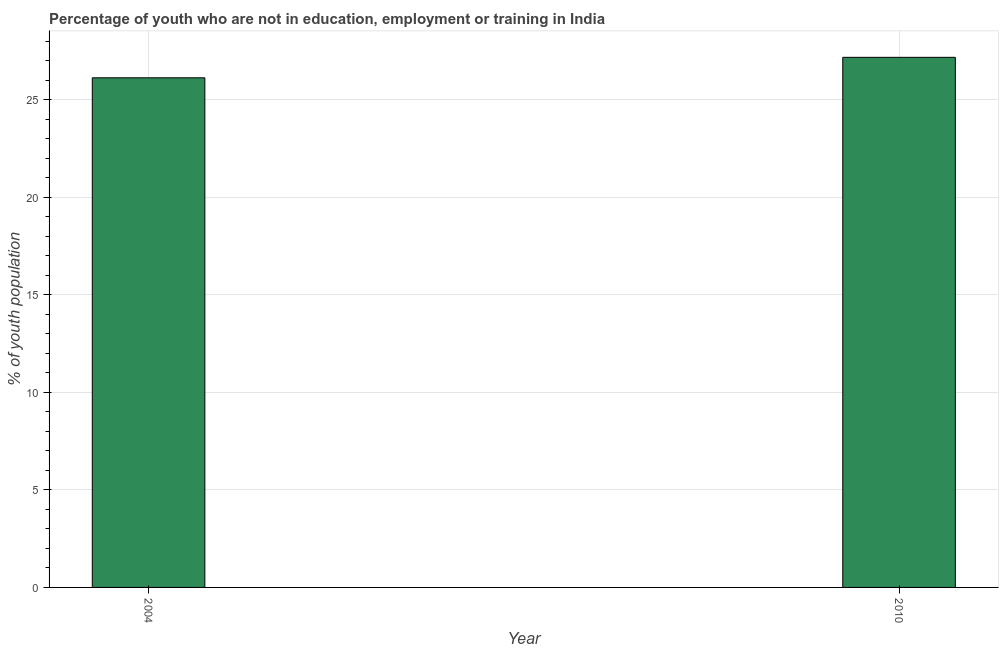Does the graph contain any zero values?
Give a very brief answer. No. Does the graph contain grids?
Your answer should be very brief. Yes. What is the title of the graph?
Offer a very short reply. Percentage of youth who are not in education, employment or training in India. What is the label or title of the Y-axis?
Ensure brevity in your answer.  % of youth population. What is the unemployed youth population in 2010?
Provide a short and direct response. 27.18. Across all years, what is the maximum unemployed youth population?
Your answer should be compact. 27.18. Across all years, what is the minimum unemployed youth population?
Offer a terse response. 26.13. In which year was the unemployed youth population maximum?
Provide a succinct answer. 2010. In which year was the unemployed youth population minimum?
Provide a succinct answer. 2004. What is the sum of the unemployed youth population?
Your response must be concise. 53.31. What is the difference between the unemployed youth population in 2004 and 2010?
Provide a short and direct response. -1.05. What is the average unemployed youth population per year?
Provide a succinct answer. 26.66. What is the median unemployed youth population?
Offer a very short reply. 26.65. Do a majority of the years between 2010 and 2004 (inclusive) have unemployed youth population greater than 12 %?
Your response must be concise. No. What is the ratio of the unemployed youth population in 2004 to that in 2010?
Your answer should be very brief. 0.96. Is the unemployed youth population in 2004 less than that in 2010?
Keep it short and to the point. Yes. How many years are there in the graph?
Provide a succinct answer. 2. What is the difference between two consecutive major ticks on the Y-axis?
Offer a terse response. 5. What is the % of youth population in 2004?
Your response must be concise. 26.13. What is the % of youth population in 2010?
Ensure brevity in your answer.  27.18. What is the difference between the % of youth population in 2004 and 2010?
Make the answer very short. -1.05. 